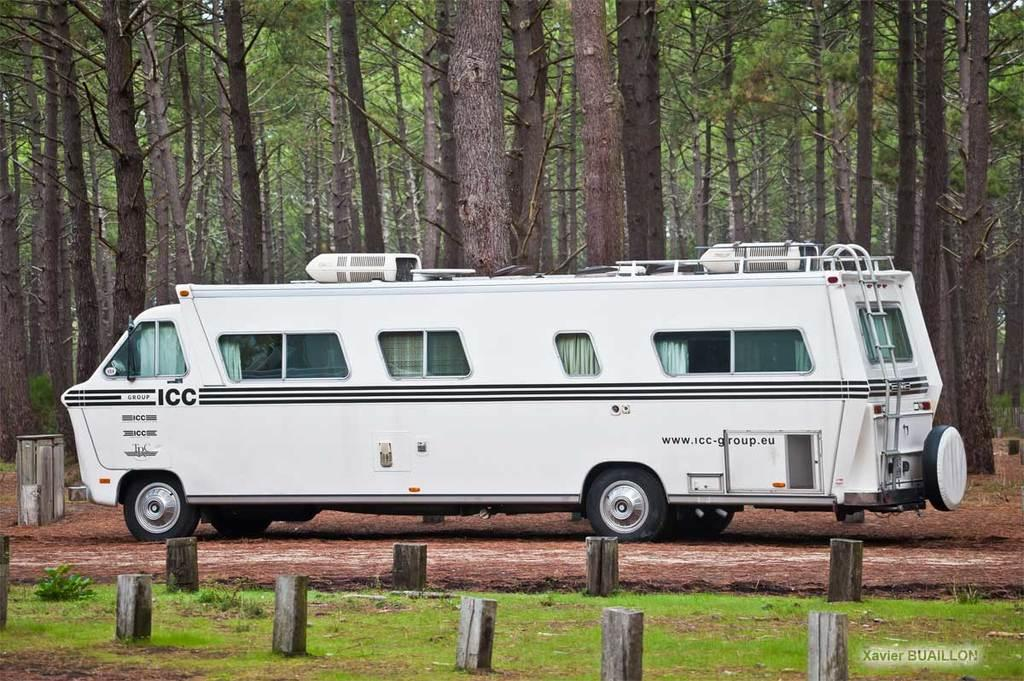What is the main object on the ground in the image? There is a vehicle on the ground in the image. What type of terrain is visible at the bottom of the image? Grass is visible at the bottom of the image. What structures can be seen at the bottom of the image? Poles are present at the bottom of the image. What can be seen in the distance in the image? There are many trees in the background of the image. What condition is the father in while visiting the location in the image? There is no father or visitor present in the image, so we cannot determine their condition. 